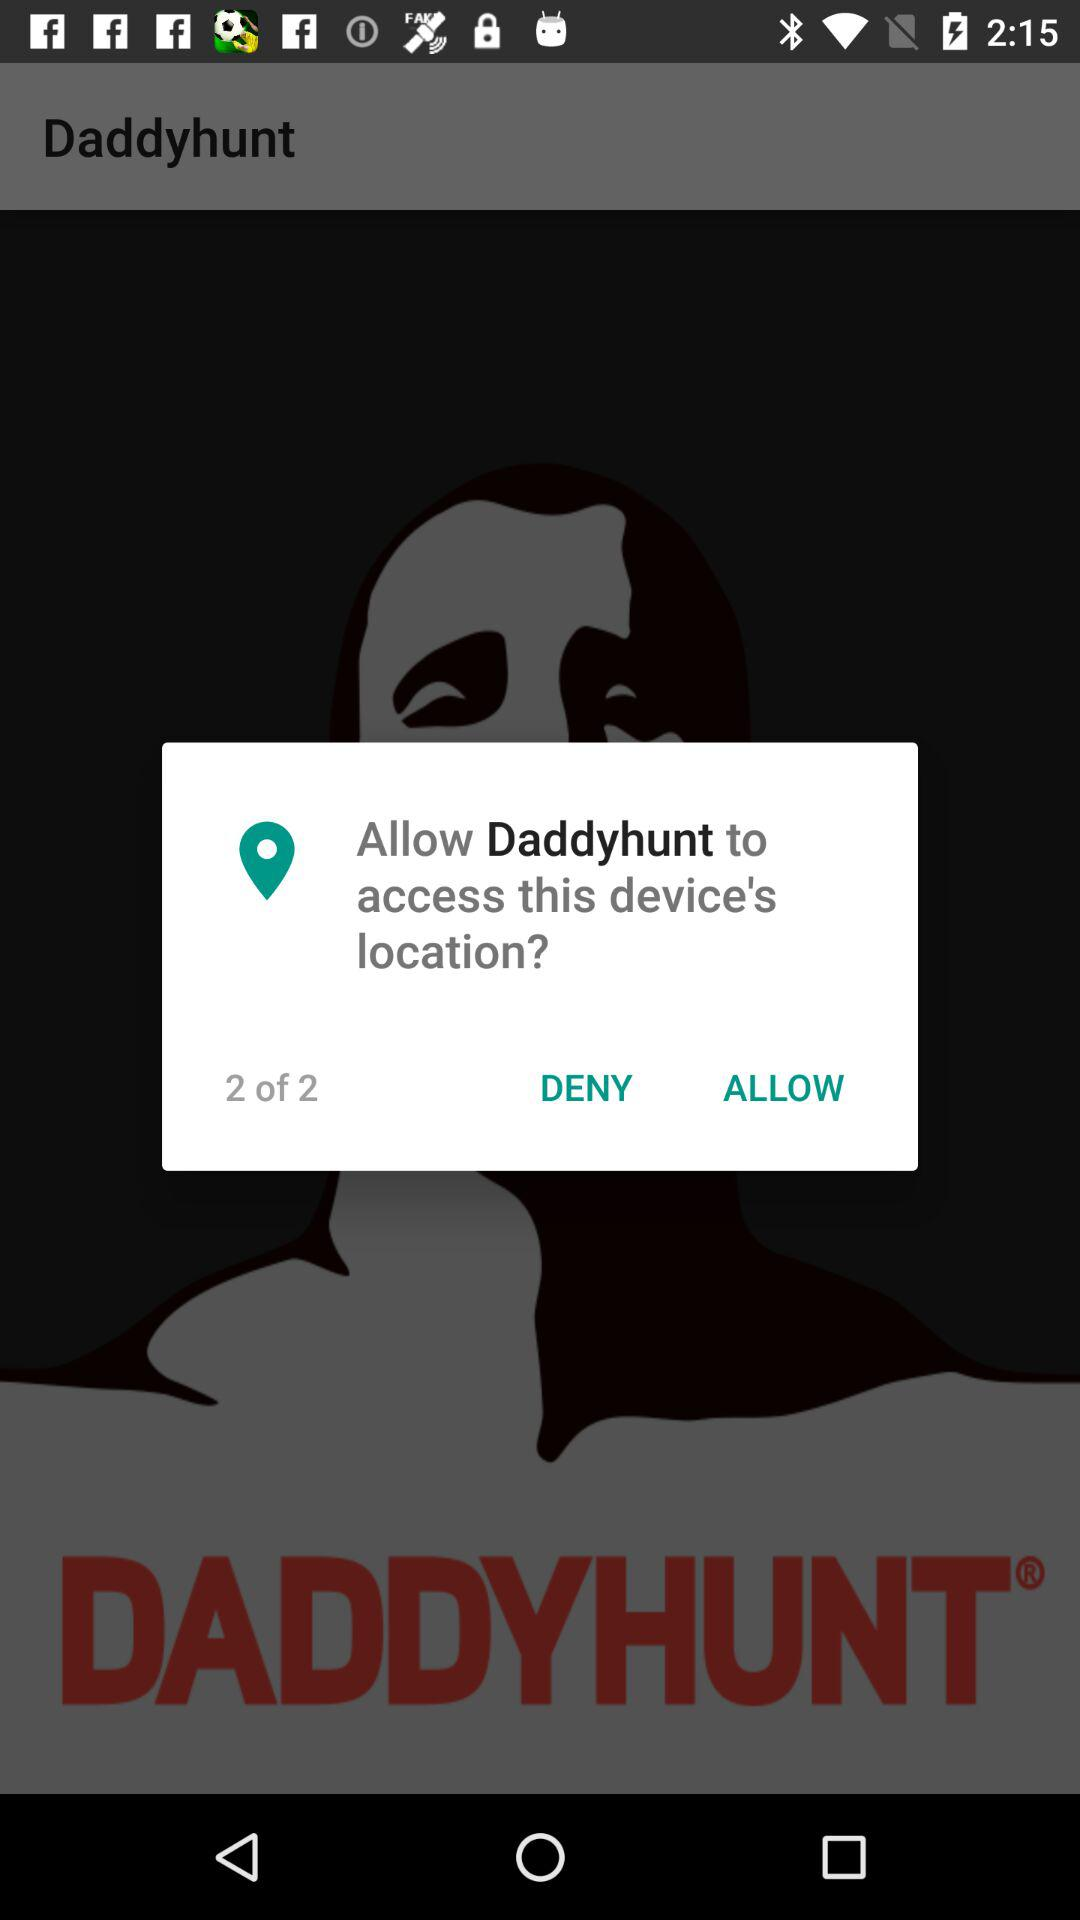What is the name of the application? The name of the application is "Daddyhunt". 